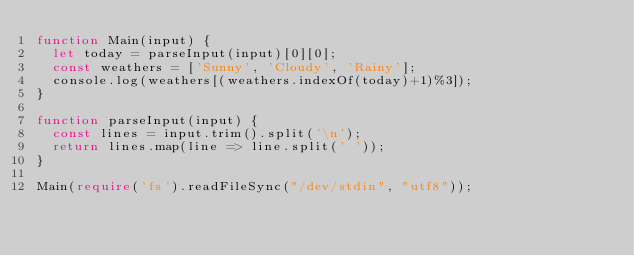<code> <loc_0><loc_0><loc_500><loc_500><_TypeScript_>function Main(input) {
  let today = parseInput(input)[0][0];
  const weathers = ['Sunny', 'Cloudy', 'Rainy'];
  console.log(weathers[(weathers.indexOf(today)+1)%3]);
}

function parseInput(input) {
  const lines = input.trim().split('\n');
  return lines.map(line => line.split(' '));
}

Main(require('fs').readFileSync("/dev/stdin", "utf8"));
</code> 